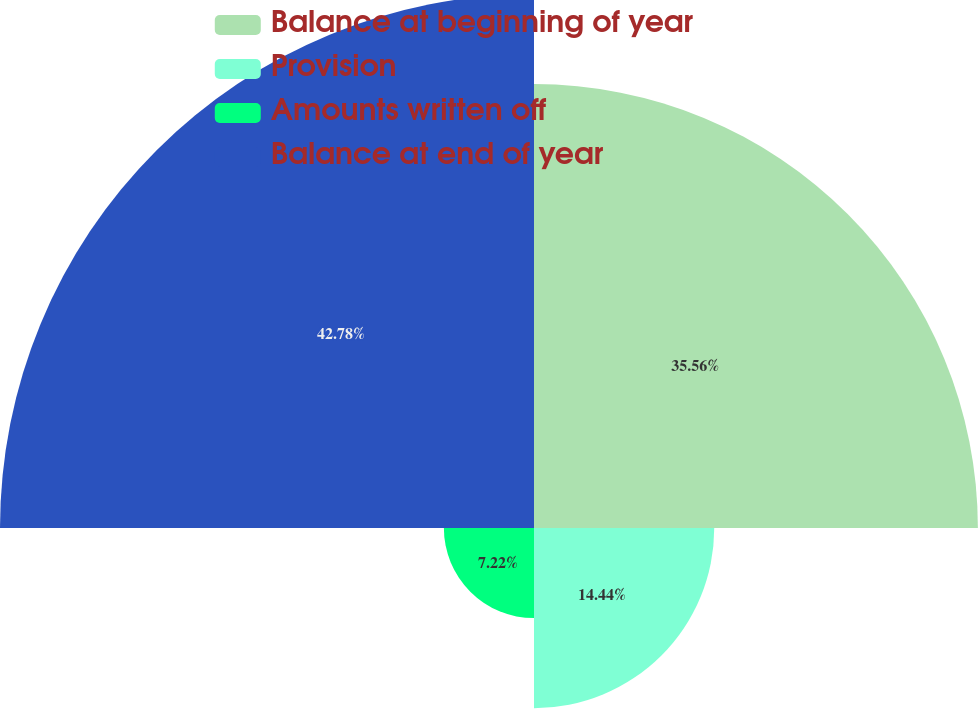Convert chart to OTSL. <chart><loc_0><loc_0><loc_500><loc_500><pie_chart><fcel>Balance at beginning of year<fcel>Provision<fcel>Amounts written off<fcel>Balance at end of year<nl><fcel>35.56%<fcel>14.44%<fcel>7.22%<fcel>42.78%<nl></chart> 